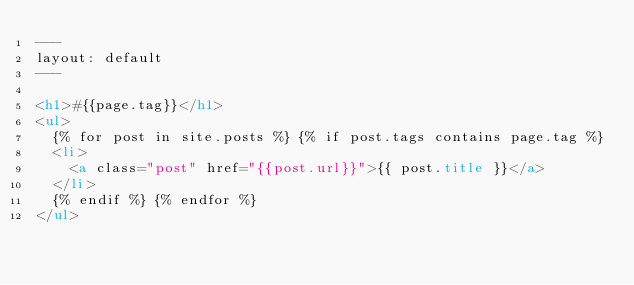Convert code to text. <code><loc_0><loc_0><loc_500><loc_500><_HTML_>---
layout: default
---

<h1>#{{page.tag}}</h1>
<ul>
  {% for post in site.posts %} {% if post.tags contains page.tag %}
  <li>
    <a class="post" href="{{post.url}}">{{ post.title }}</a>
  </li>
  {% endif %} {% endfor %}
</ul>
</code> 